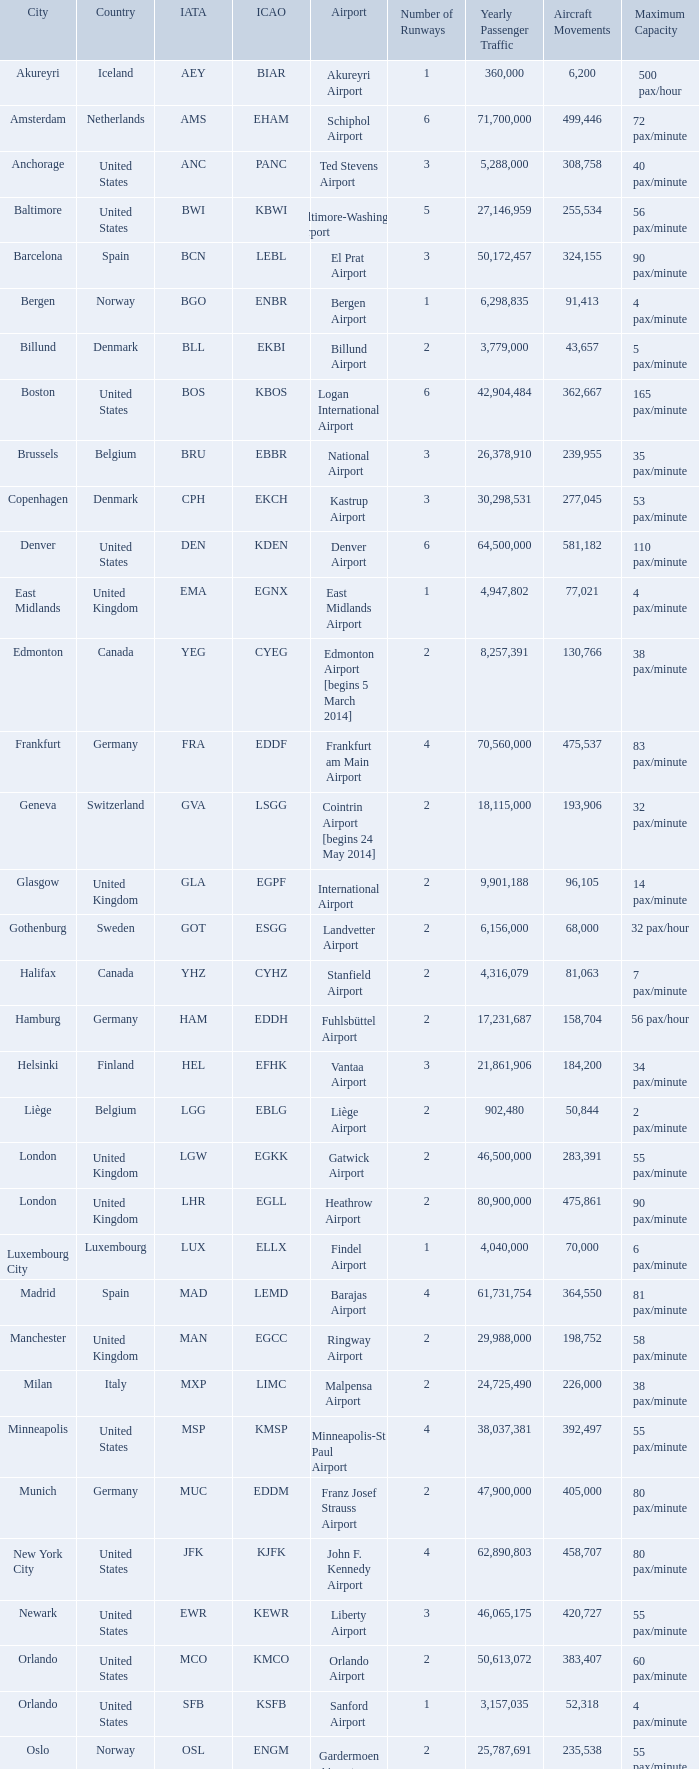What is the City with an IATA of MUC? Munich. Give me the full table as a dictionary. {'header': ['City', 'Country', 'IATA', 'ICAO', 'Airport', 'Number of Runways', 'Yearly Passenger Traffic', 'Aircraft Movements', 'Maximum Capacity'], 'rows': [['Akureyri', 'Iceland', 'AEY', 'BIAR', 'Akureyri Airport', '1', '360,000', '6,200', '500 pax/hour'], ['Amsterdam', 'Netherlands', 'AMS', 'EHAM', 'Schiphol Airport', '6', '71,700,000', '499,446', '72 pax/minute'], ['Anchorage', 'United States', 'ANC', 'PANC', 'Ted Stevens Airport', '3', '5,288,000', '308,758', '40 pax/minute'], ['Baltimore', 'United States', 'BWI', 'KBWI', 'Baltimore-Washington Airport', '5', '27,146,959', '255,534', '56 pax/minute'], ['Barcelona', 'Spain', 'BCN', 'LEBL', 'El Prat Airport', '3', '50,172,457', '324,155', '90 pax/minute'], ['Bergen', 'Norway', 'BGO', 'ENBR', 'Bergen Airport', '1', '6,298,835', '91,413', '4 pax/minute'], ['Billund', 'Denmark', 'BLL', 'EKBI', 'Billund Airport', '2', '3,779,000', '43,657', '5 pax/minute'], ['Boston', 'United States', 'BOS', 'KBOS', 'Logan International Airport', '6', '42,904,484', '362,667', '165 pax/minute'], ['Brussels', 'Belgium', 'BRU', 'EBBR', 'National Airport', '3', '26,378,910', '239,955', '35 pax/minute'], ['Copenhagen', 'Denmark', 'CPH', 'EKCH', 'Kastrup Airport', '3', '30,298,531', '277,045', '53 pax/minute'], ['Denver', 'United States', 'DEN', 'KDEN', 'Denver Airport', '6', '64,500,000', '581,182', '110 pax/minute'], ['East Midlands', 'United Kingdom', 'EMA', 'EGNX', 'East Midlands Airport', '1', '4,947,802', '77,021', '4 pax/minute'], ['Edmonton', 'Canada', 'YEG', 'CYEG', 'Edmonton Airport [begins 5 March 2014]', '2', '8,257,391', '130,766', '38 pax/minute'], ['Frankfurt', 'Germany', 'FRA', 'EDDF', 'Frankfurt am Main Airport', '4', '70,560,000', '475,537', '83 pax/minute'], ['Geneva', 'Switzerland', 'GVA', 'LSGG', 'Cointrin Airport [begins 24 May 2014]', '2', '18,115,000', '193,906', '32 pax/minute'], ['Glasgow', 'United Kingdom', 'GLA', 'EGPF', 'International Airport', '2', '9,901,188', '96,105', '14 pax/minute'], ['Gothenburg', 'Sweden', 'GOT', 'ESGG', 'Landvetter Airport', '2', '6,156,000', '68,000', '32 pax/hour'], ['Halifax', 'Canada', 'YHZ', 'CYHZ', 'Stanfield Airport', '2', '4,316,079', '81,063', '7 pax/minute'], ['Hamburg', 'Germany', 'HAM', 'EDDH', 'Fuhlsbüttel Airport', '2', '17,231,687', '158,704', '56 pax/hour'], ['Helsinki', 'Finland', 'HEL', 'EFHK', 'Vantaa Airport', '3', '21,861,906', '184,200', '34 pax/minute'], ['Liège', 'Belgium', 'LGG', 'EBLG', 'Liège Airport', '2', '902,480', '50,844', '2 pax/minute'], ['London', 'United Kingdom', 'LGW', 'EGKK', 'Gatwick Airport', '2', '46,500,000', '283,391', '55 pax/minute'], ['London', 'United Kingdom', 'LHR', 'EGLL', 'Heathrow Airport', '2', '80,900,000', '475,861', '90 pax/minute'], ['Luxembourg City', 'Luxembourg', 'LUX', 'ELLX', 'Findel Airport', '1', '4,040,000', '70,000', '6 pax/minute'], ['Madrid', 'Spain', 'MAD', 'LEMD', 'Barajas Airport', '4', '61,731,754', '364,550', '81 pax/minute'], ['Manchester', 'United Kingdom', 'MAN', 'EGCC', 'Ringway Airport', '2', '29,988,000', '198,752', '58 pax/minute'], ['Milan', 'Italy', 'MXP', 'LIMC', 'Malpensa Airport', '2', '24,725,490', '226,000', '38 pax/minute'], ['Minneapolis', 'United States', 'MSP', 'KMSP', 'Minneapolis-St Paul Airport', '4', '38,037,381', '392,497', '55 pax/minute'], ['Munich', 'Germany', 'MUC', 'EDDM', 'Franz Josef Strauss Airport', '2', '47,900,000', '405,000', '80 pax/minute'], ['New York City', 'United States', 'JFK', 'KJFK', 'John F. Kennedy Airport', '4', '62,890,803', '458,707', '80 pax/minute'], ['Newark', 'United States', 'EWR', 'KEWR', 'Liberty Airport', '3', '46,065,175', '420,727', '55 pax/minute'], ['Orlando', 'United States', 'MCO', 'KMCO', 'Orlando Airport', '2', '50,613,072', '383,407', '60 pax/minute'], ['Orlando', 'United States', 'SFB', 'KSFB', 'Sanford Airport', '1', '3,157,035', '52,318', '4 pax/minute'], ['Oslo', 'Norway', 'OSL', 'ENGM', 'Gardermoen Airport', '2', '25,787,691', '235,538', '55 pax/minute'], ['Paris', 'France', 'CDG', 'LFPG', 'Charles de Gaulle Airport', '4', '72,229,723', '475,654', '95 pax/minute'], ['Reykjavík', 'Iceland', 'KEF', 'BIKF', 'Keflavik Airport', '1', '8,755,000', '84,200', '8 pax/minute'], ['Saint Petersburg', 'Russia', 'LED', 'ULLI', 'Pulkovo Airport', '3', '19,951,000', '166,000', '24 pax/minute'], ['San Francisco', 'United States', 'SFO', 'KSFO', 'San Francisco Airport', '4', '57,793,313', '470,755', '80 pax/minute'], ['Seattle', 'United States', 'SEA', 'KSEA', 'Seattle–Tacoma Airport', '3', '49,849,520', '425,800', '70 pax/minute'], ['Stavanger', 'Norway', 'SVG', 'ENZV', 'Sola Airport', '1', '4,664,919', '65,571', '10 pax/hour'], ['Stockholm', 'Sweden', 'ARN', 'ESSA', 'Arlanda Airport', '4', '25,946,000', '216,000', '35 pax/minute'], ['Toronto', 'Canada', 'YYZ', 'CYYZ', 'Pearson Airport', '5', '49,507,418', '468,480', '135 pax/minute'], ['Trondheim', 'Norway', 'TRD', 'ENVA', 'Trondheim Airport', '1', '4,880,000', '69,091', '5 pax/minute'], ['Vancouver', 'Canada', 'YVR', 'CYVR', 'Vancouver Airport [begins 13 May 2014]', '3', '25,936,000', '332,277', '60 pax/minute'], ['Washington, D.C.', 'United States', 'IAD', 'KIAD', 'Dulles Airport', '2', '24,097,044', '215,399', '60 pax/minute'], ['Zurich', 'Switzerland', 'ZRH', 'LSZH', 'Kloten Airport', '3', '31,150,000', '267,504', '66 pax/minute']]} 